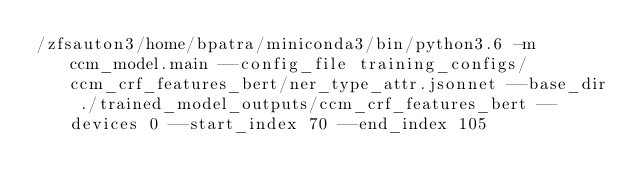<code> <loc_0><loc_0><loc_500><loc_500><_Bash_>/zfsauton3/home/bpatra/miniconda3/bin/python3.6 -m ccm_model.main --config_file training_configs/ccm_crf_features_bert/ner_type_attr.jsonnet --base_dir ./trained_model_outputs/ccm_crf_features_bert --devices 0 --start_index 70 --end_index 105
</code> 